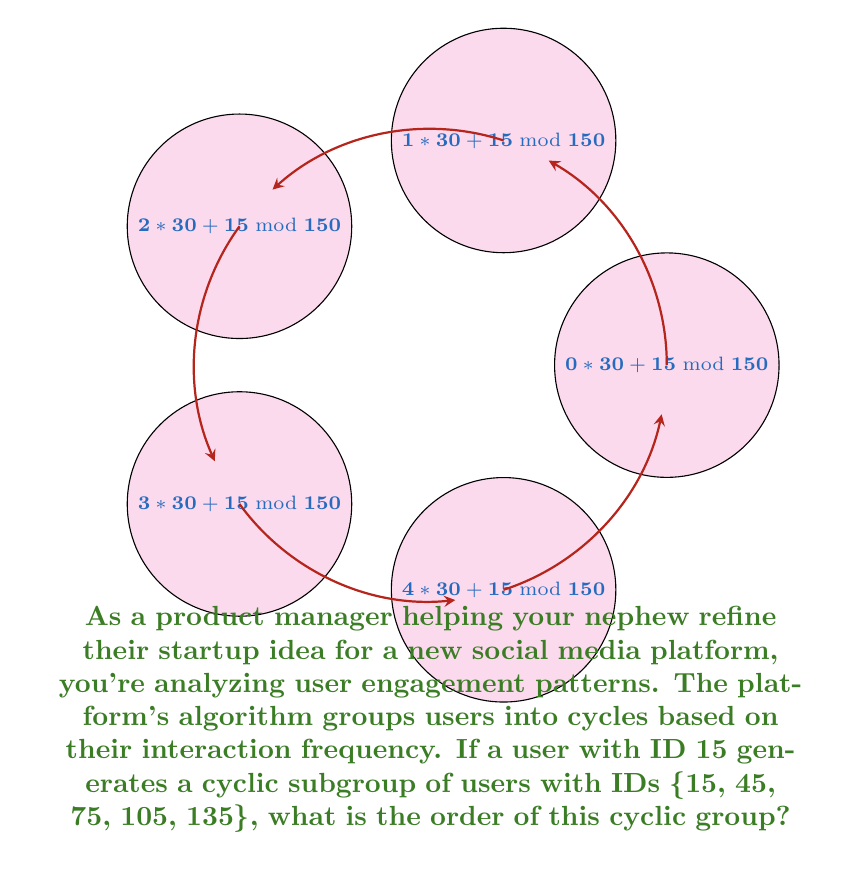Can you solve this math problem? To determine the order of a cyclic group generated by a given element, we need to follow these steps:

1) First, let's understand what the cyclic subgroup represents:
   {15, 45, 75, 105, 135}

2) We can see that each element is obtained by adding 30 to the previous element (mod 150):
   15 + 30 = 45
   45 + 30 = 75
   75 + 30 = 105
   105 + 30 = 135
   135 + 30 = 15 (mod 150)

3) The order of a cyclic group is the number of unique elements in the group before it repeats.

4) In this case, we can count the elements:
   {15, 45, 75, 105, 135}

5) There are 5 unique elements before the cycle repeats.

Therefore, the order of this cyclic group is 5.

This can also be verified mathematically:
Let $a = 15$ be the generator of the group.
The order of $a$ is the smallest positive integer $n$ such that $a^n = e$ (identity element).
In this case, $15n \equiv 0 \pmod{150}$ for $n = 5$ (since $15 \cdot 5 = 75$, and $75 \cdot 2 = 150$).
Answer: 5 